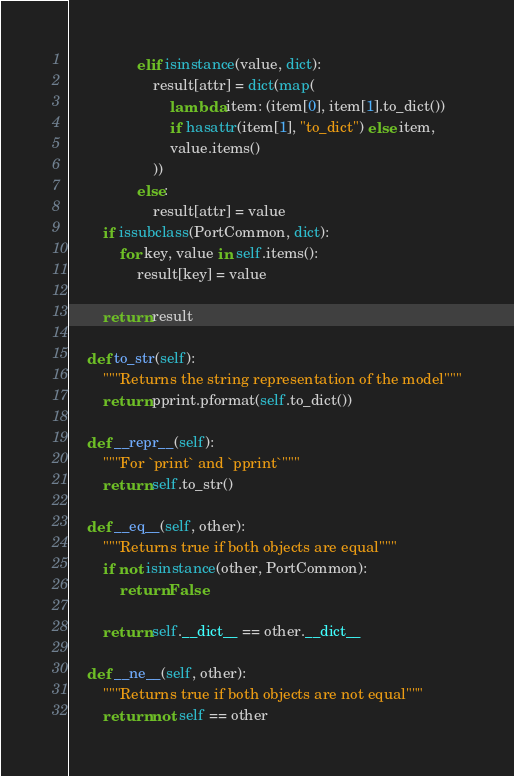<code> <loc_0><loc_0><loc_500><loc_500><_Python_>                elif isinstance(value, dict):
                    result[attr] = dict(map(
                        lambda item: (item[0], item[1].to_dict())
                        if hasattr(item[1], "to_dict") else item,
                        value.items()
                    ))
                else:
                    result[attr] = value
        if issubclass(PortCommon, dict):
            for key, value in self.items():
                result[key] = value

        return result

    def to_str(self):
        """Returns the string representation of the model"""
        return pprint.pformat(self.to_dict())

    def __repr__(self):
        """For `print` and `pprint`"""
        return self.to_str()

    def __eq__(self, other):
        """Returns true if both objects are equal"""
        if not isinstance(other, PortCommon):
            return False

        return self.__dict__ == other.__dict__

    def __ne__(self, other):
        """Returns true if both objects are not equal"""
        return not self == other
</code> 